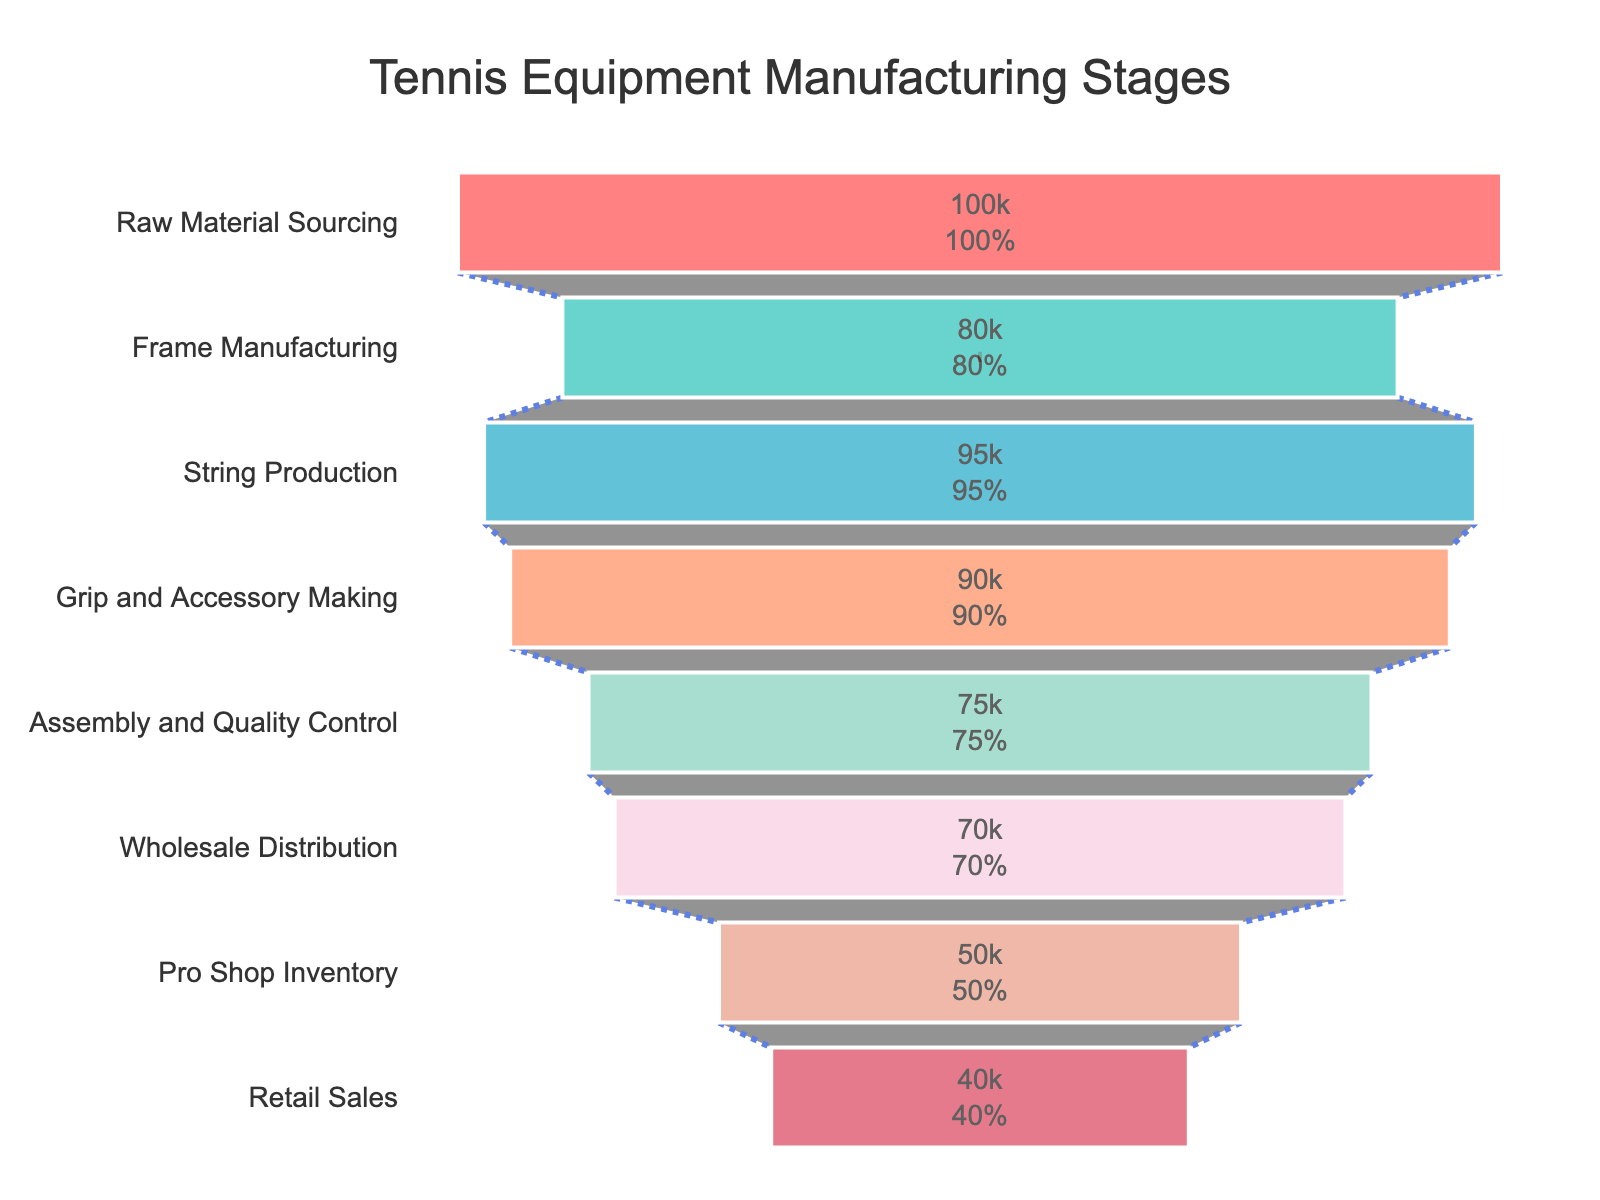How many stages are there in the manufacturing process displayed in the figure? There are 8 stages listed: "Raw Material Sourcing," "Frame Manufacturing," "String Production," "Grip and Accessory Making," "Assembly and Quality Control," "Wholesale Distribution," "Pro Shop Inventory," and "Retail Sales."
Answer: 8 What is the title of the funnel chart? The title is displayed at the top of the chart. It commonly gives an overview of the chart's content. The title is "Tennis Equipment Manufacturing Stages."
Answer: Tennis Equipment Manufacturing Stages Which stage has the highest number of units? By looking at the heights of the segments in the funnel chart and the numerical values inside them, the "Raw Material Sourcing" stage has the highest number of units with 100,000 units.
Answer: Raw Material Sourcing What is the difference in the number of units between the "Raw Material Sourcing" and "Retail Sales" stages? The "Raw Material Sourcing" stage has 100,000 units and the "Retail Sales" stage has 40,000 units. The difference is calculated as 100,000 - 40,000 = 60,000 units.
Answer: 60,000 Which stage represents the most significant drop in the number of units from the previous stage? By examining the decrease in units between consecutive stages, the drop between "Pro Shop Inventory" (50,000 units) and "Retail Sales" (40,000 units) is noticeable. The difference is 10,000 units, which is the largest single-stage drop in the chart.
Answer: Pro Shop Inventory to Retail Sales What percentage of the initial units are left by the "Wholesale Distribution" stage? The initial stage, "Raw Material Sourcing," starts with 100,000 units. By the "Wholesale Distribution" stage, there are 70,000 units remaining. The percentage is calculated as (70,000 / 100,000) * 100 = 70%.
Answer: 70% Across how many stages do more than 75% of the initial units remain? 75% of the initial units (100,000) is 75,000 units. "Raw Material Sourcing" (100,000 units), "Frame Manufacturing" (80,000 units), "String Production" (95,000 units), and "Grip and Accessory Making" (90,000 units) all have more than 75,000 units. This covers 4 stages.
Answer: 4 Which stage has a greater number of units: "Frame Manufacturing" or "String Production"? By comparing the numerical values, "String Production" has 95,000 units whereas "Frame Manufacturing" has 80,000 units. Therefore, "String Production" has a greater number of units.
Answer: String Production How many units are lost after the "Assembly and Quality Control" stage? The "Assembly and Quality Control" stage has 75,000 units, and the next stage, "Wholesale Distribution," has 70,000 units. The number of units lost is calculated as 75,000 - 70,000 = 5,000 units.
Answer: 5,000 What visual elements are used to distinguish different stages in the funnel? The chart uses various distinctive features like color coding, text positioning, value display inside the segments, and lines to separate each stage. This makes it easier to differentiate between the stages.
Answer: Color, text position, value display, lines 